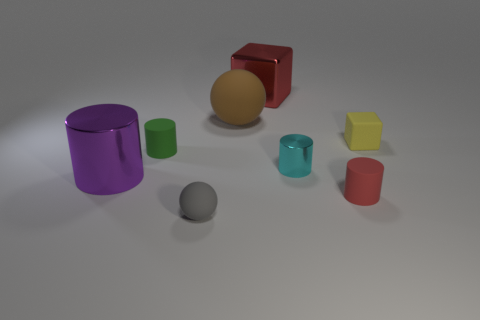Is there a ball that has the same material as the yellow cube?
Your answer should be compact. Yes. Are there fewer small yellow cubes left of the metallic block than tiny blue things?
Provide a short and direct response. No. There is a red thing behind the big object left of the small green rubber thing; what is its material?
Ensure brevity in your answer.  Metal. There is a tiny matte thing that is both to the right of the cyan shiny cylinder and on the left side of the tiny yellow cube; what shape is it?
Make the answer very short. Cylinder. How many other things are the same color as the big metallic cylinder?
Give a very brief answer. 0. What number of objects are metal objects behind the brown rubber sphere or small brown things?
Ensure brevity in your answer.  1. Does the large metal cube have the same color as the small matte cylinder that is on the right side of the cyan object?
Provide a succinct answer. Yes. There is a sphere that is behind the metal cylinder that is in front of the cyan metal cylinder; what size is it?
Offer a very short reply. Large. How many things are large purple cylinders or small matte objects to the right of the green rubber object?
Offer a terse response. 4. There is a red object in front of the purple object; is its shape the same as the big red metallic thing?
Give a very brief answer. No. 